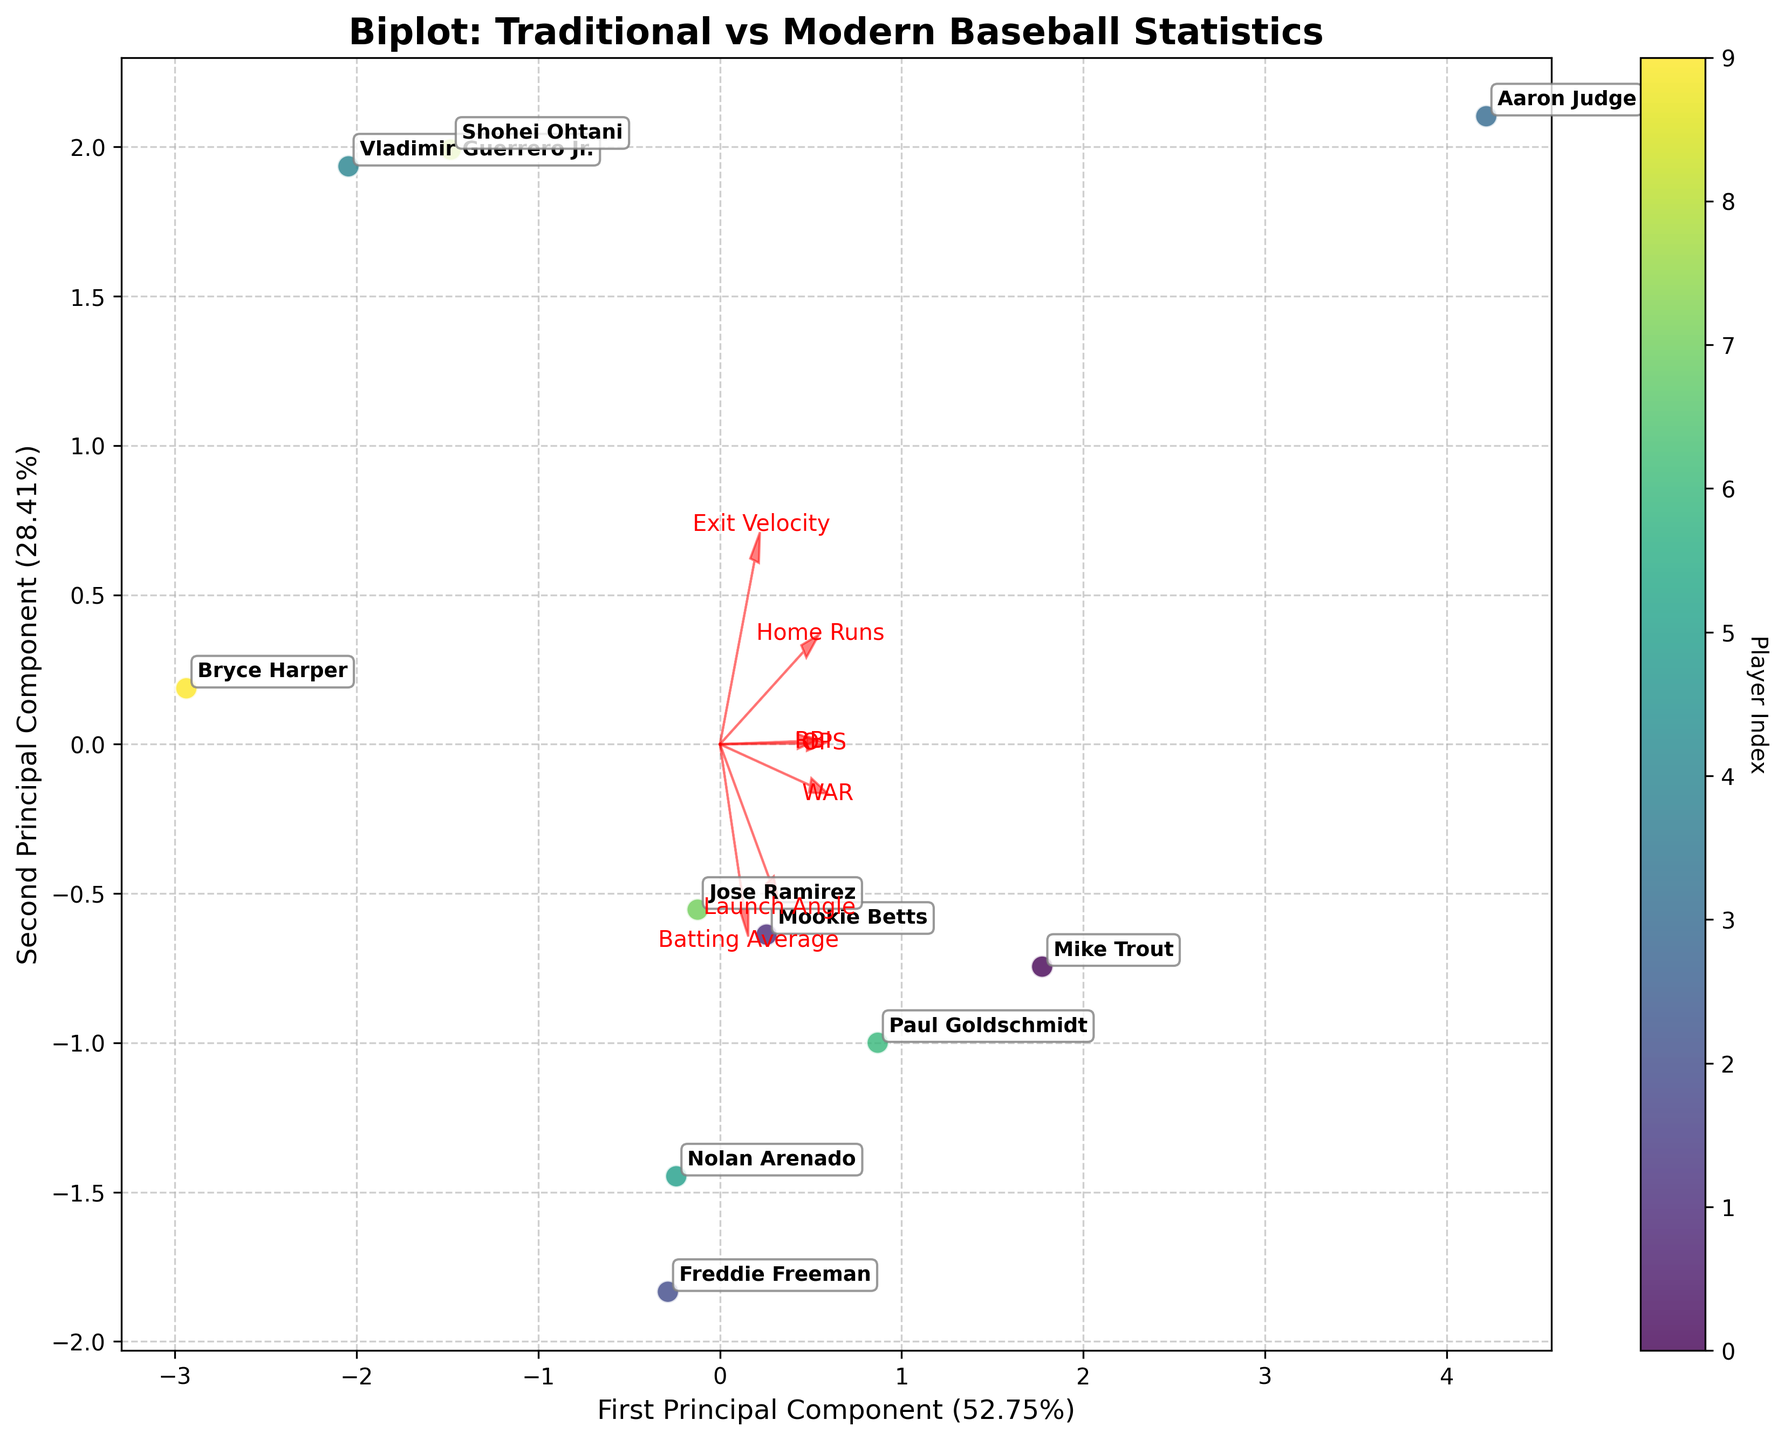How many players are represented in the biplot? The plot shows a scatter of points, each labeled with a player's name. Count the number of labeled points.
Answer: 10 What are the two principal components labeled on the axes? The axes are labeled with the first and second principal components along with their explained variance percentage. Check the axes' labels.
Answer: First Principal Component, Second Principal Component Which player has the highest value along the first principal component? Locate the point that is farthest to the right along the x-axis (first principal component) and identify the player label.
Answer: Aaron Judge Which feature vector has the longest arrow in the biplot, and what does it imply? Look at the length of the red arrows representing each feature. The longest arrow indicates the feature with the highest variance in principal components.
Answer: Home Runs Do traditional stats like batting average and modern stats like exit velocity align closely on the plot? Check the direction and proximity of the arrows for batting average and exit velocity. Compare their angles and whether they point in a similar direction.
Answer: No Which two players are closest together in the biplot, and what might this indicate? Identify two points that are closest to each other and read the corresponding player names. This suggests similarities in their statistical profiles.
Answer: Mookie Betts, Paul Goldschmidt Which feature seems to contribute the least to the second principal component? Compare the arrows' directions and lengths; the feature with the shortest arrow along the y-axis has the smallest contribution.
Answer: Launch Angle What can you infer about a player if their point is aligned closely with the "WAR" feature vector? Players near the "WAR" vector likely have substantial wins above replacement contributions, indicating high overall value.
Answer: High WAR How much variance do the first and second principal components explain together? Add the explained variance percentages given in the axis labels to determine the cumulative variance explanation.
Answer: Sum of percentages (e.g., 40% + 30%) 